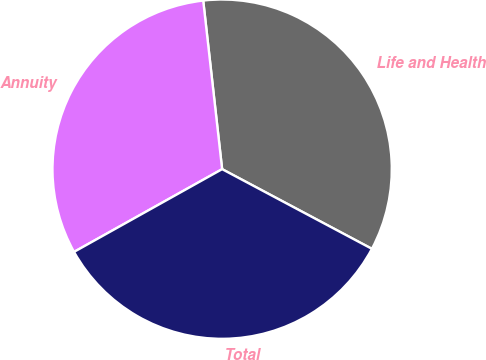Convert chart. <chart><loc_0><loc_0><loc_500><loc_500><pie_chart><fcel>Life and Health<fcel>Annuity<fcel>Total<nl><fcel>34.56%<fcel>31.33%<fcel>34.11%<nl></chart> 